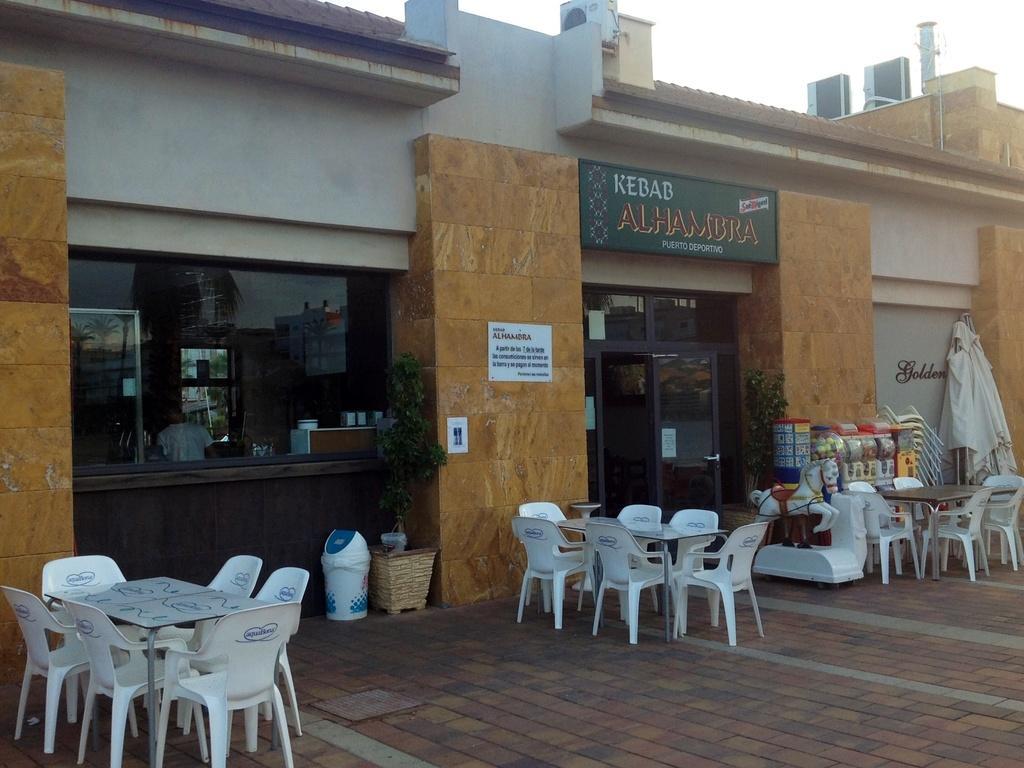Could you give a brief overview of what you see in this image? This image consists of a store, tables and chairs. The Store has a door and there are persons in that store. On that store that is Kebab written on it. 